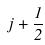Convert formula to latex. <formula><loc_0><loc_0><loc_500><loc_500>j + \frac { 1 } { 2 }</formula> 